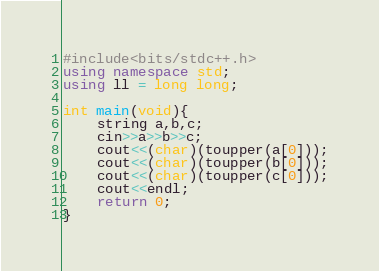<code> <loc_0><loc_0><loc_500><loc_500><_C++_>#include<bits/stdc++.h>
using namespace std;
using ll = long long;

int main(void){
    string a,b,c;
    cin>>a>>b>>c;
    cout<<(char)(toupper(a[0]));
    cout<<(char)(toupper(b[0]));
    cout<<(char)(toupper(c[0]));
    cout<<endl;
    return 0;
}</code> 